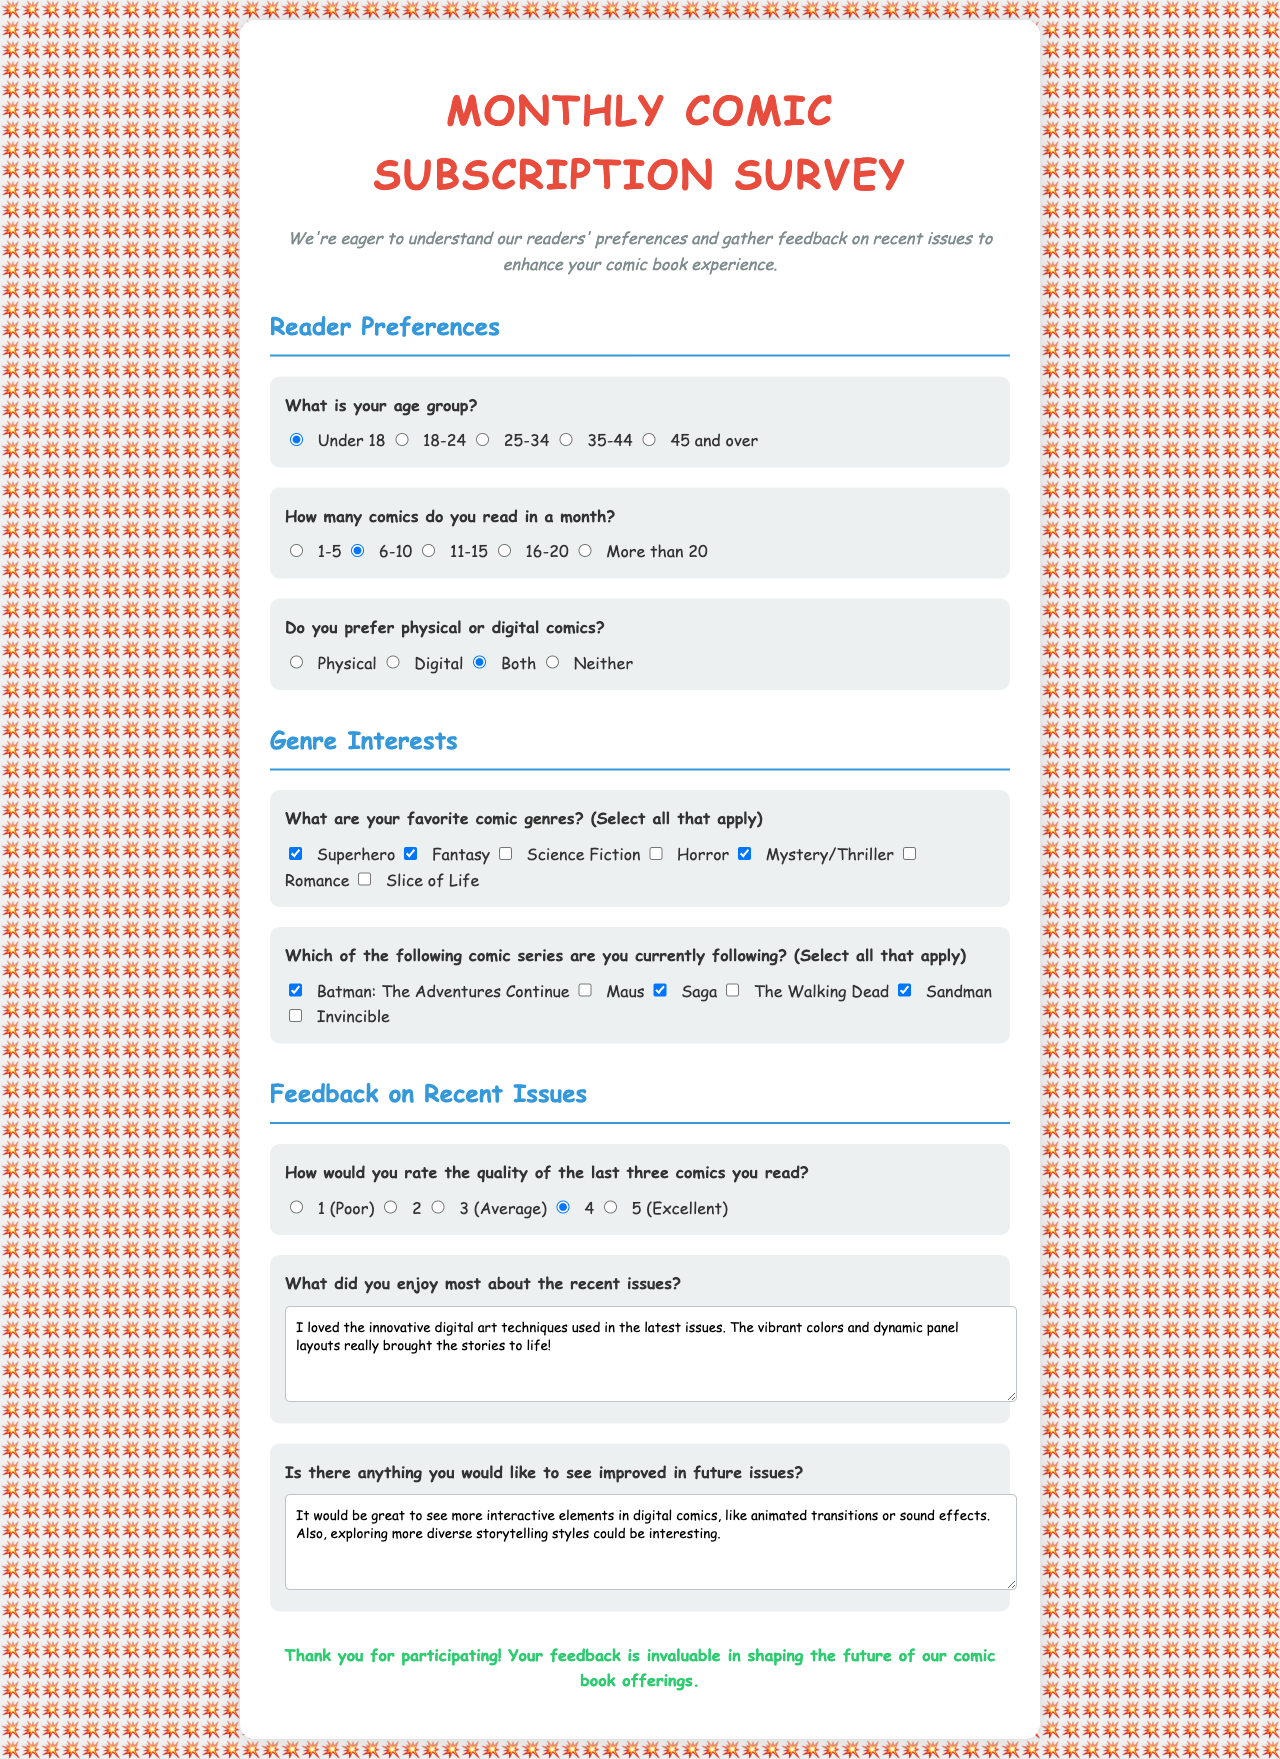What is the title of the survey? The title of the survey is presented in the document as "Monthly Comic Subscription Survey."
Answer: Monthly Comic Subscription Survey What age group is most commonly represented in the responses? The default selected age group in the survey is "Under 18," indicating this is a common representation.
Answer: Under 18 How many comics does the respondent read in a month? The selected option for how many comics the respondent reads is "6-10."
Answer: 6-10 What genre is not checked in the favorite comic genres? The genre "Science Fiction" is not checked among the favorite genres.
Answer: Science Fiction Which comic series is listed among those currently followed? "Batman: The Adventures Continue" is checked as a series currently being followed.
Answer: Batman: The Adventures Continue What rating was given for the quality of the last three comics read? The selected rating for the last three comics read is "4."
Answer: 4 What did the respondent enjoy most about the recent issues? The respondent enjoyed the "innovative digital art techniques used in the latest issues."
Answer: innovative digital art techniques What improvement does the respondent suggest for future issues? The respondent suggests more "interactive elements in digital comics."
Answer: interactive elements Which formatting preference was selected in the survey? The selected formatting preference is "Both."
Answer: Both 